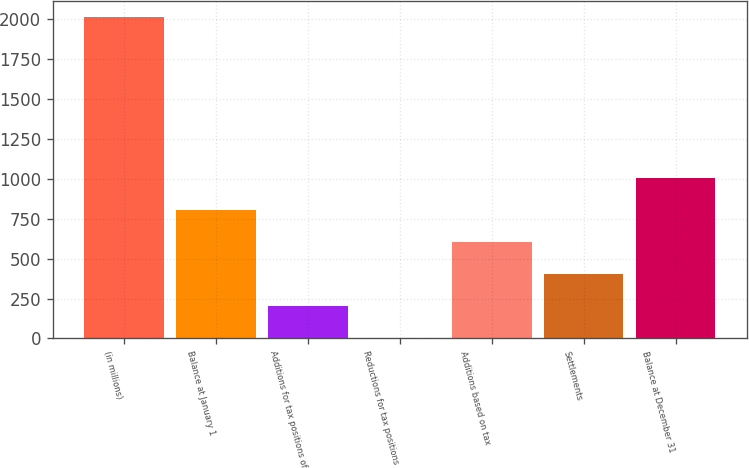<chart> <loc_0><loc_0><loc_500><loc_500><bar_chart><fcel>(in millions)<fcel>Balance at January 1<fcel>Additions for tax positions of<fcel>Reductions for tax positions<fcel>Additions based on tax<fcel>Settlements<fcel>Balance at December 31<nl><fcel>2012<fcel>805.4<fcel>202.1<fcel>1<fcel>604.3<fcel>403.2<fcel>1006.5<nl></chart> 